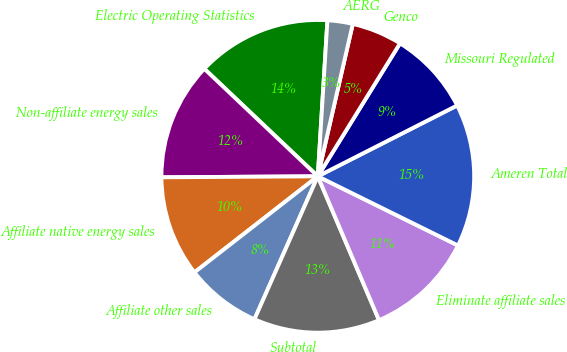Convert chart. <chart><loc_0><loc_0><loc_500><loc_500><pie_chart><fcel>Electric Operating Statistics<fcel>Non-affiliate energy sales<fcel>Affiliate native energy sales<fcel>Affiliate other sales<fcel>Subtotal<fcel>Eliminate affiliate sales<fcel>Ameren Total<fcel>Missouri Regulated<fcel>Genco<fcel>AERG<nl><fcel>13.91%<fcel>12.17%<fcel>10.43%<fcel>7.83%<fcel>13.04%<fcel>11.3%<fcel>14.78%<fcel>8.7%<fcel>5.22%<fcel>2.61%<nl></chart> 